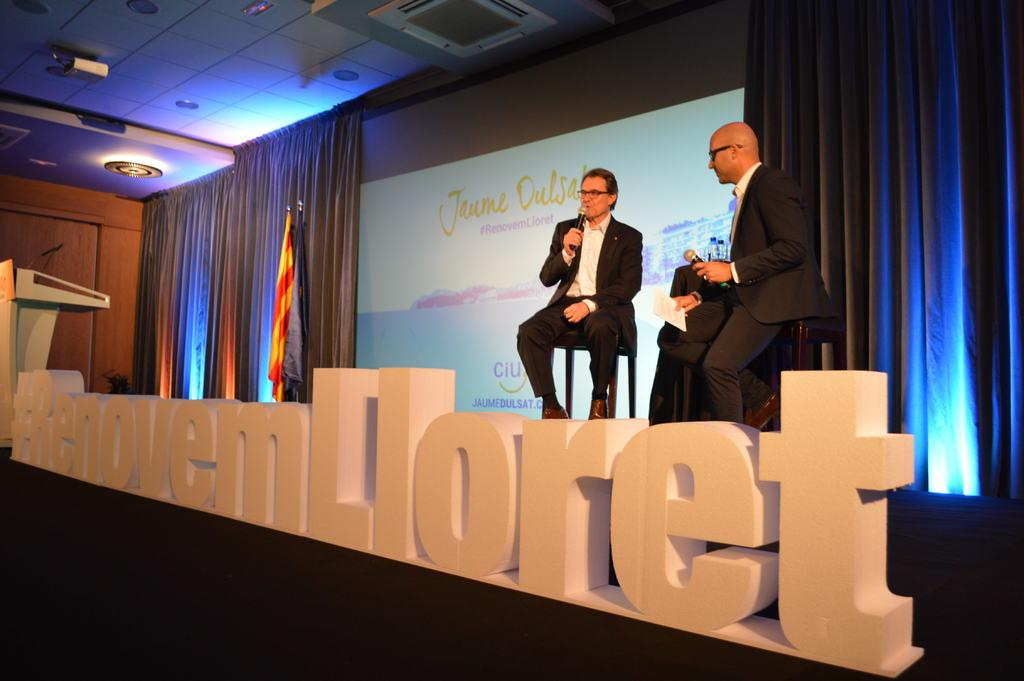<image>
Create a compact narrative representing the image presented. Two men sit behind large wording wiht the end saying Lloret. 